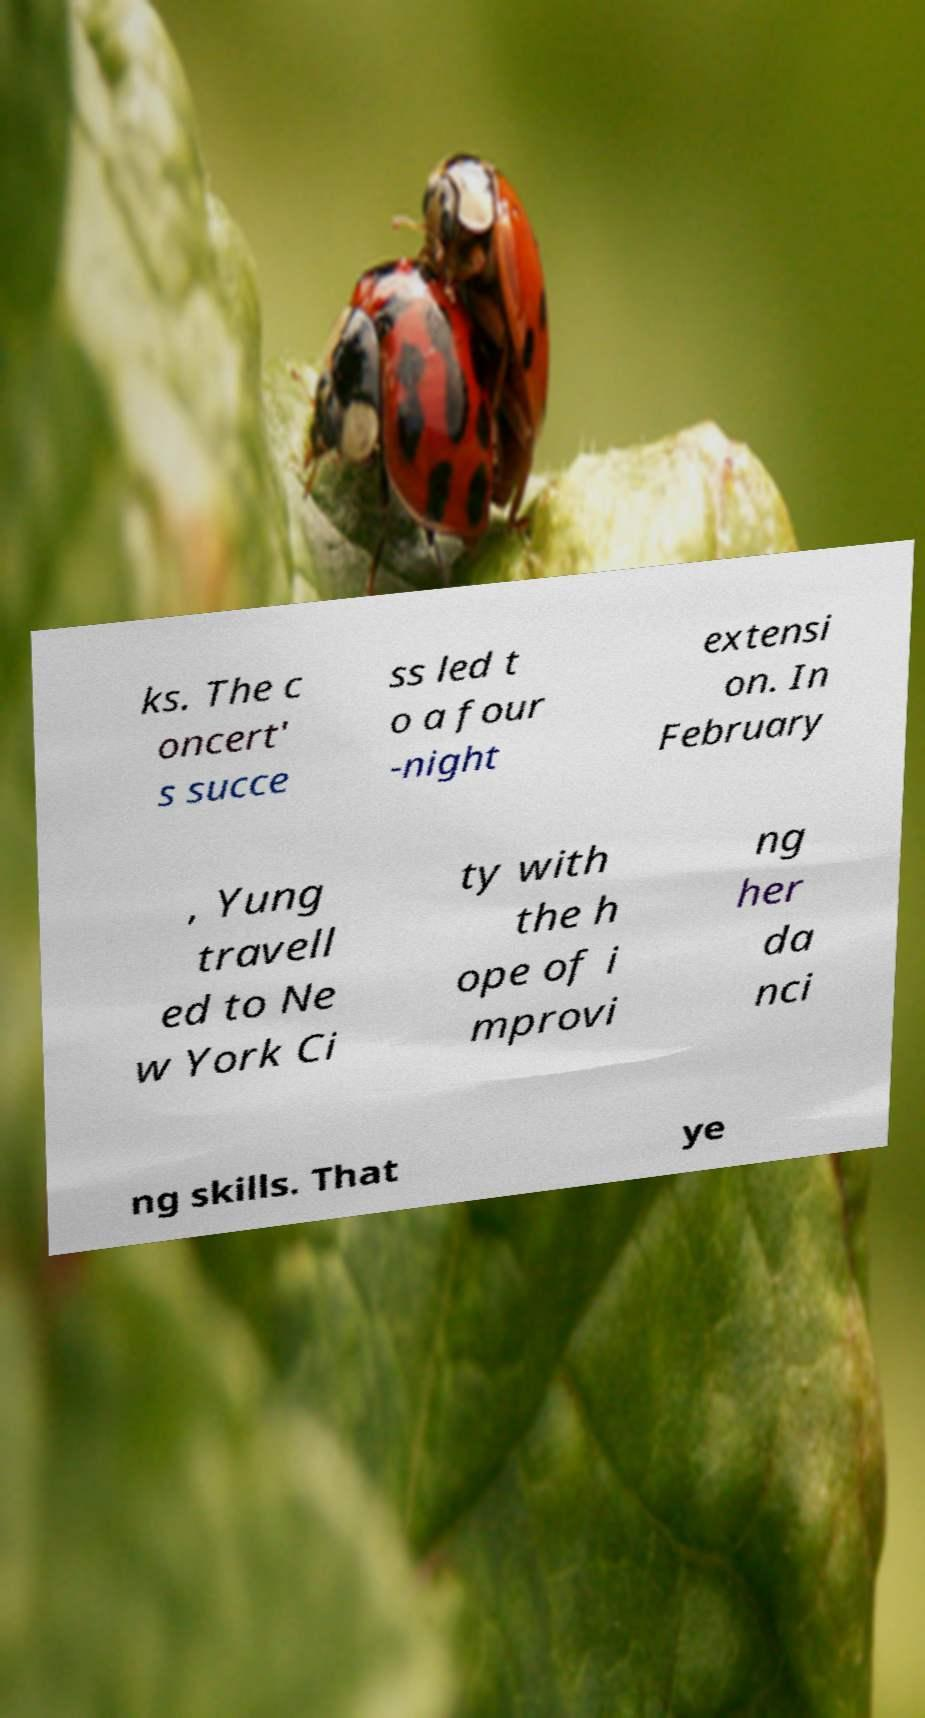Could you assist in decoding the text presented in this image and type it out clearly? ks. The c oncert' s succe ss led t o a four -night extensi on. In February , Yung travell ed to Ne w York Ci ty with the h ope of i mprovi ng her da nci ng skills. That ye 